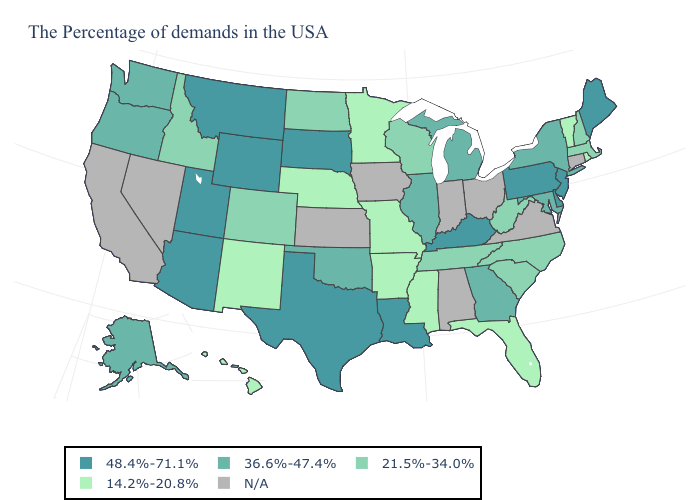Which states have the highest value in the USA?
Answer briefly. Maine, New Jersey, Delaware, Pennsylvania, Kentucky, Louisiana, Texas, South Dakota, Wyoming, Utah, Montana, Arizona. Is the legend a continuous bar?
Keep it brief. No. Name the states that have a value in the range N/A?
Answer briefly. Connecticut, Virginia, Ohio, Indiana, Alabama, Iowa, Kansas, Nevada, California. Which states have the highest value in the USA?
Keep it brief. Maine, New Jersey, Delaware, Pennsylvania, Kentucky, Louisiana, Texas, South Dakota, Wyoming, Utah, Montana, Arizona. Which states hav the highest value in the Northeast?
Answer briefly. Maine, New Jersey, Pennsylvania. Does the map have missing data?
Be succinct. Yes. What is the highest value in states that border Michigan?
Write a very short answer. 21.5%-34.0%. Name the states that have a value in the range 14.2%-20.8%?
Keep it brief. Rhode Island, Vermont, Florida, Mississippi, Missouri, Arkansas, Minnesota, Nebraska, New Mexico, Hawaii. Among the states that border Colorado , does Oklahoma have the highest value?
Keep it brief. No. Name the states that have a value in the range N/A?
Quick response, please. Connecticut, Virginia, Ohio, Indiana, Alabama, Iowa, Kansas, Nevada, California. What is the lowest value in the USA?
Be succinct. 14.2%-20.8%. Name the states that have a value in the range 36.6%-47.4%?
Give a very brief answer. New York, Maryland, Georgia, Michigan, Illinois, Oklahoma, Washington, Oregon, Alaska. Which states have the lowest value in the USA?
Keep it brief. Rhode Island, Vermont, Florida, Mississippi, Missouri, Arkansas, Minnesota, Nebraska, New Mexico, Hawaii. How many symbols are there in the legend?
Quick response, please. 5. 